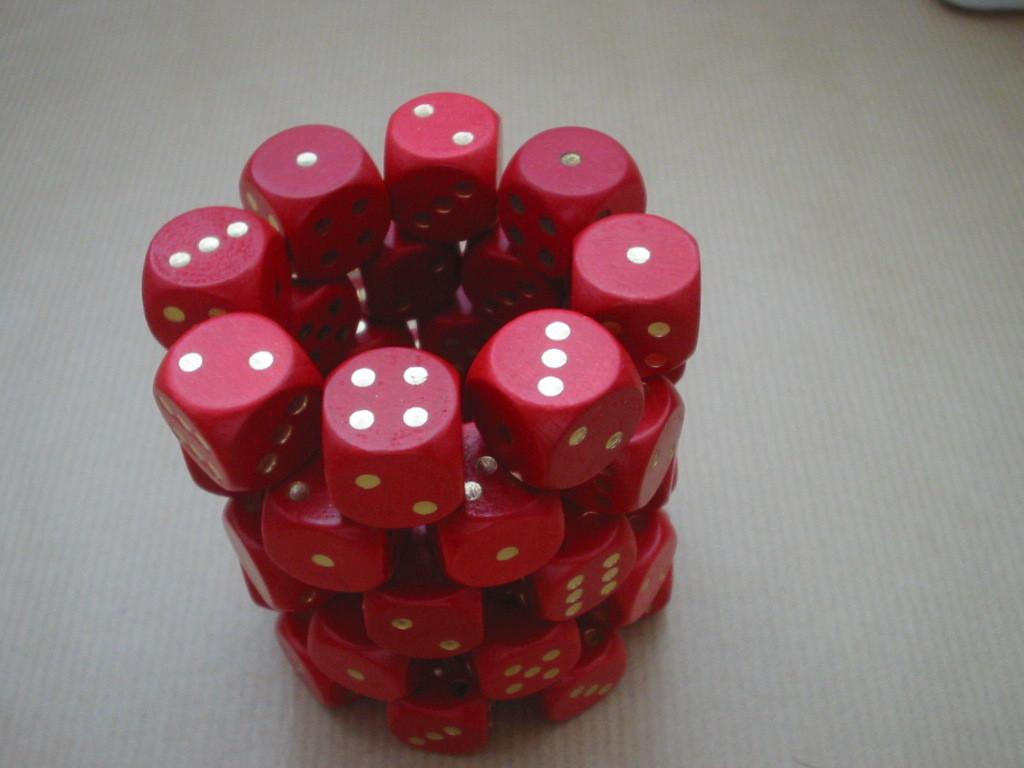What objects are the main focus of the image? There is a group of dice in the image. How are the dice arranged in the image? The dice are arranged in a structure. What color are the dice in the image? The dice are red in color. What type of produce can be seen growing in the image? There is no produce visible in the image; it features a group of red dice arranged in a structure. Can you tell me how many buttons are on the dice in the image? The dice in the image do not have buttons; they are solid red objects. 